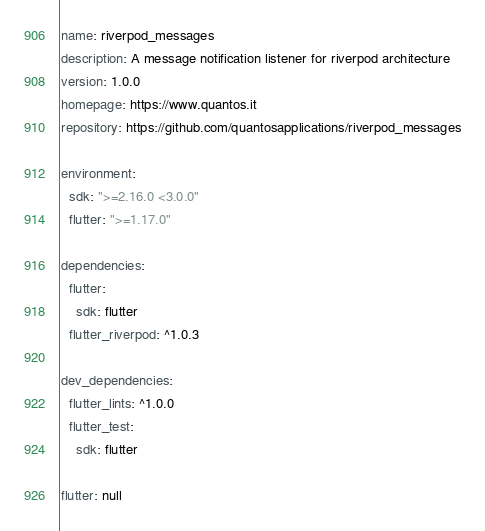Convert code to text. <code><loc_0><loc_0><loc_500><loc_500><_YAML_>name: riverpod_messages
description: A message notification listener for riverpod architecture
version: 1.0.0
homepage: https://www.quantos.it
repository: https://github.com/quantosapplications/riverpod_messages

environment:
  sdk: ">=2.16.0 <3.0.0"
  flutter: ">=1.17.0"

dependencies:
  flutter:
    sdk: flutter
  flutter_riverpod: ^1.0.3

dev_dependencies:
  flutter_lints: ^1.0.0
  flutter_test:
    sdk: flutter

flutter: null
</code> 